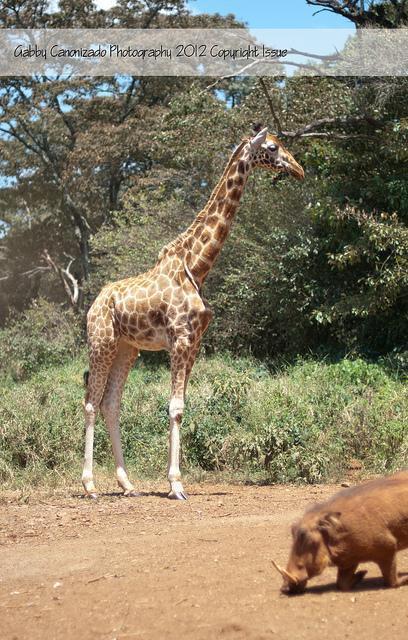How many horses are in the picture?
Give a very brief answer. 0. 